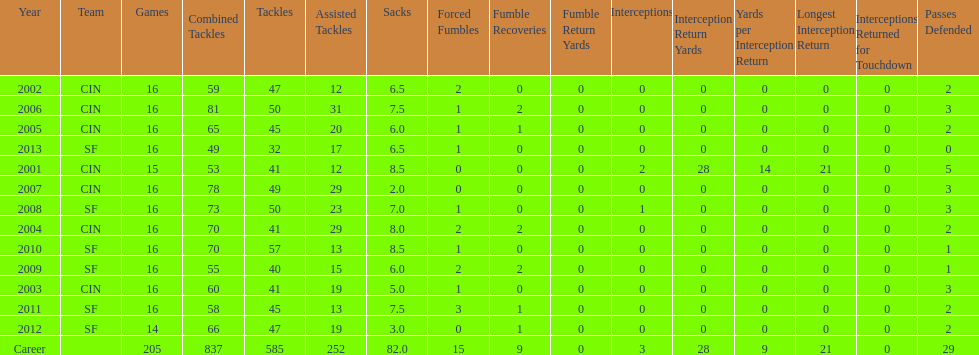In 2004, how many fumble recoveries were made by this player? 2. Would you mind parsing the complete table? {'header': ['Year', 'Team', 'Games', 'Combined Tackles', 'Tackles', 'Assisted Tackles', 'Sacks', 'Forced Fumbles', 'Fumble Recoveries', 'Fumble Return Yards', 'Interceptions', 'Interception Return Yards', 'Yards per Interception Return', 'Longest Interception Return', 'Interceptions Returned for Touchdown', 'Passes Defended'], 'rows': [['2002', 'CIN', '16', '59', '47', '12', '6.5', '2', '0', '0', '0', '0', '0', '0', '0', '2'], ['2006', 'CIN', '16', '81', '50', '31', '7.5', '1', '2', '0', '0', '0', '0', '0', '0', '3'], ['2005', 'CIN', '16', '65', '45', '20', '6.0', '1', '1', '0', '0', '0', '0', '0', '0', '2'], ['2013', 'SF', '16', '49', '32', '17', '6.5', '1', '0', '0', '0', '0', '0', '0', '0', '0'], ['2001', 'CIN', '15', '53', '41', '12', '8.5', '0', '0', '0', '2', '28', '14', '21', '0', '5'], ['2007', 'CIN', '16', '78', '49', '29', '2.0', '0', '0', '0', '0', '0', '0', '0', '0', '3'], ['2008', 'SF', '16', '73', '50', '23', '7.0', '1', '0', '0', '1', '0', '0', '0', '0', '3'], ['2004', 'CIN', '16', '70', '41', '29', '8.0', '2', '2', '0', '0', '0', '0', '0', '0', '2'], ['2010', 'SF', '16', '70', '57', '13', '8.5', '1', '0', '0', '0', '0', '0', '0', '0', '1'], ['2009', 'SF', '16', '55', '40', '15', '6.0', '2', '2', '0', '0', '0', '0', '0', '0', '1'], ['2003', 'CIN', '16', '60', '41', '19', '5.0', '1', '0', '0', '0', '0', '0', '0', '0', '3'], ['2011', 'SF', '16', '58', '45', '13', '7.5', '3', '1', '0', '0', '0', '0', '0', '0', '2'], ['2012', 'SF', '14', '66', '47', '19', '3.0', '0', '1', '0', '0', '0', '0', '0', '0', '2'], ['Career', '', '205', '837', '585', '252', '82.0', '15', '9', '0', '3', '28', '9', '21', '0', '29']]} 